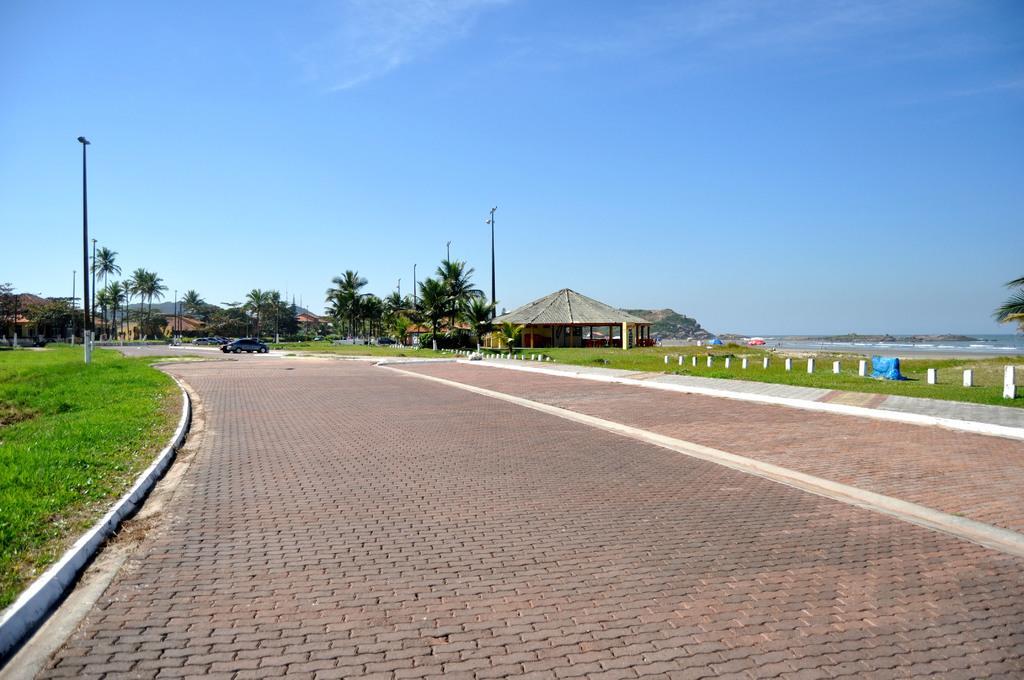Please provide a concise description of this image. In this picture we can observe a path here. There is a car parked here. In the left side there is some grass on the ground. We can observe some poles in this picture. There is a hut. In the right side there is an ocean. In the background there are trees and houses. We can observe a sky. 